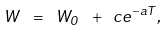<formula> <loc_0><loc_0><loc_500><loc_500>W \ = \ W _ { 0 } \ + \ c e ^ { - a T } ,</formula> 